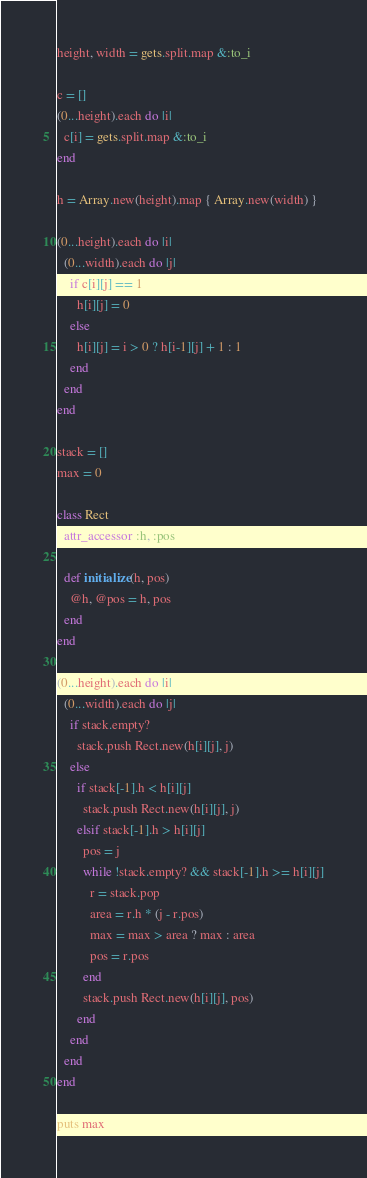Convert code to text. <code><loc_0><loc_0><loc_500><loc_500><_Ruby_>height, width = gets.split.map &:to_i

c = []
(0...height).each do |i|
  c[i] = gets.split.map &:to_i
end

h = Array.new(height).map { Array.new(width) }

(0...height).each do |i|
  (0...width).each do |j|
    if c[i][j] == 1
      h[i][j] = 0
    else
      h[i][j] = i > 0 ? h[i-1][j] + 1 : 1
    end
  end
end

stack = []
max = 0

class Rect
  attr_accessor :h, :pos

  def initialize(h, pos)
    @h, @pos = h, pos
  end
end

(0...height).each do |i|
  (0...width).each do |j|
    if stack.empty?
      stack.push Rect.new(h[i][j], j)
    else
      if stack[-1].h < h[i][j]
        stack.push Rect.new(h[i][j], j)
      elsif stack[-1].h > h[i][j]
        pos = j
        while !stack.empty? && stack[-1].h >= h[i][j]
          r = stack.pop
          area = r.h * (j - r.pos)
          max = max > area ? max : area
          pos = r.pos
        end
        stack.push Rect.new(h[i][j], pos)
      end
    end
  end
end

puts max</code> 